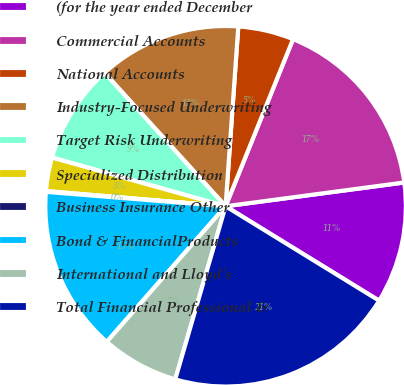<chart> <loc_0><loc_0><loc_500><loc_500><pie_chart><fcel>(for the year ended December<fcel>Commercial Accounts<fcel>National Accounts<fcel>Industry-Focused Underwriting<fcel>Target Risk Underwriting<fcel>Specialized Distribution<fcel>Business Insurance Other<fcel>Bond & FinancialProducts<fcel>International and Lloyd's<fcel>Total Financial Professional &<nl><fcel>10.88%<fcel>16.79%<fcel>4.98%<fcel>12.85%<fcel>8.92%<fcel>3.01%<fcel>0.07%<fcel>14.82%<fcel>6.95%<fcel>20.73%<nl></chart> 